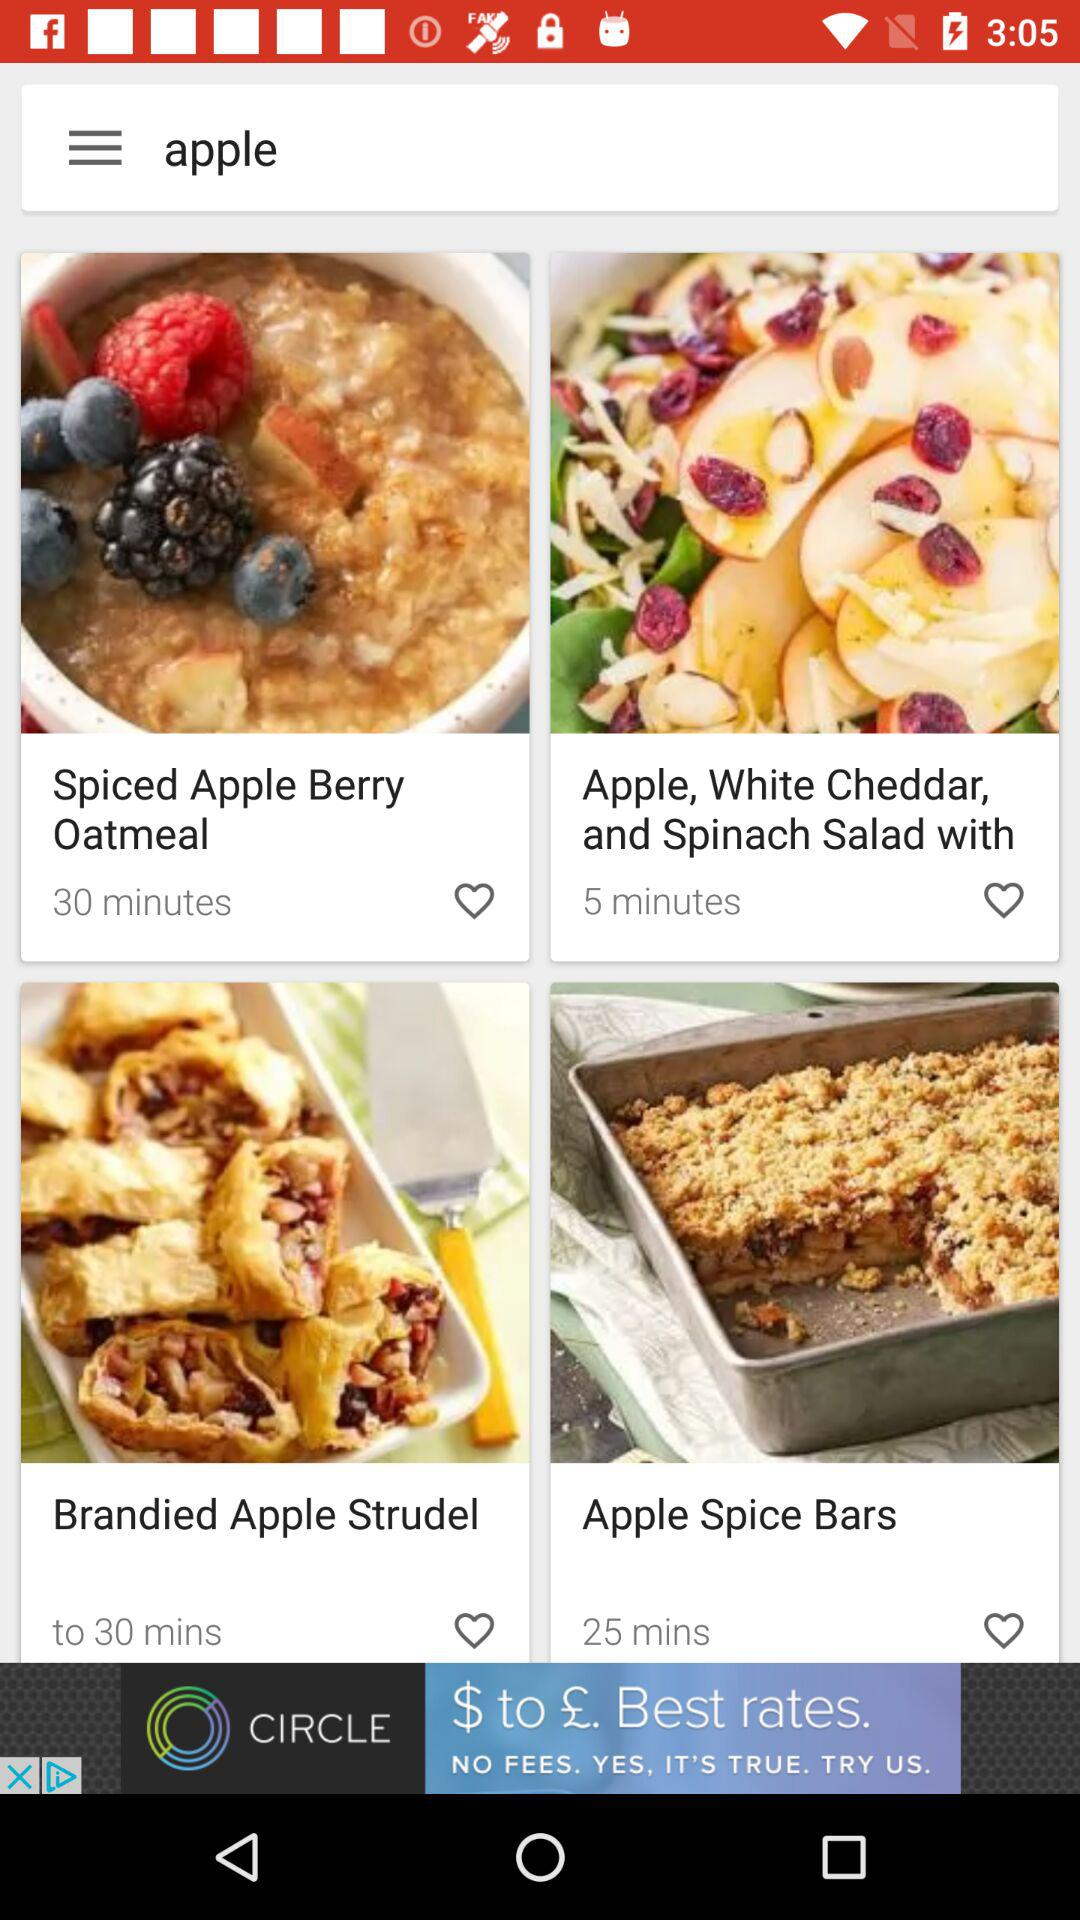How much time will it take to prepare spiced apple berry oatmeal? The time it takes to prepare spiced apple berry oatmeal is 30 minutes. 